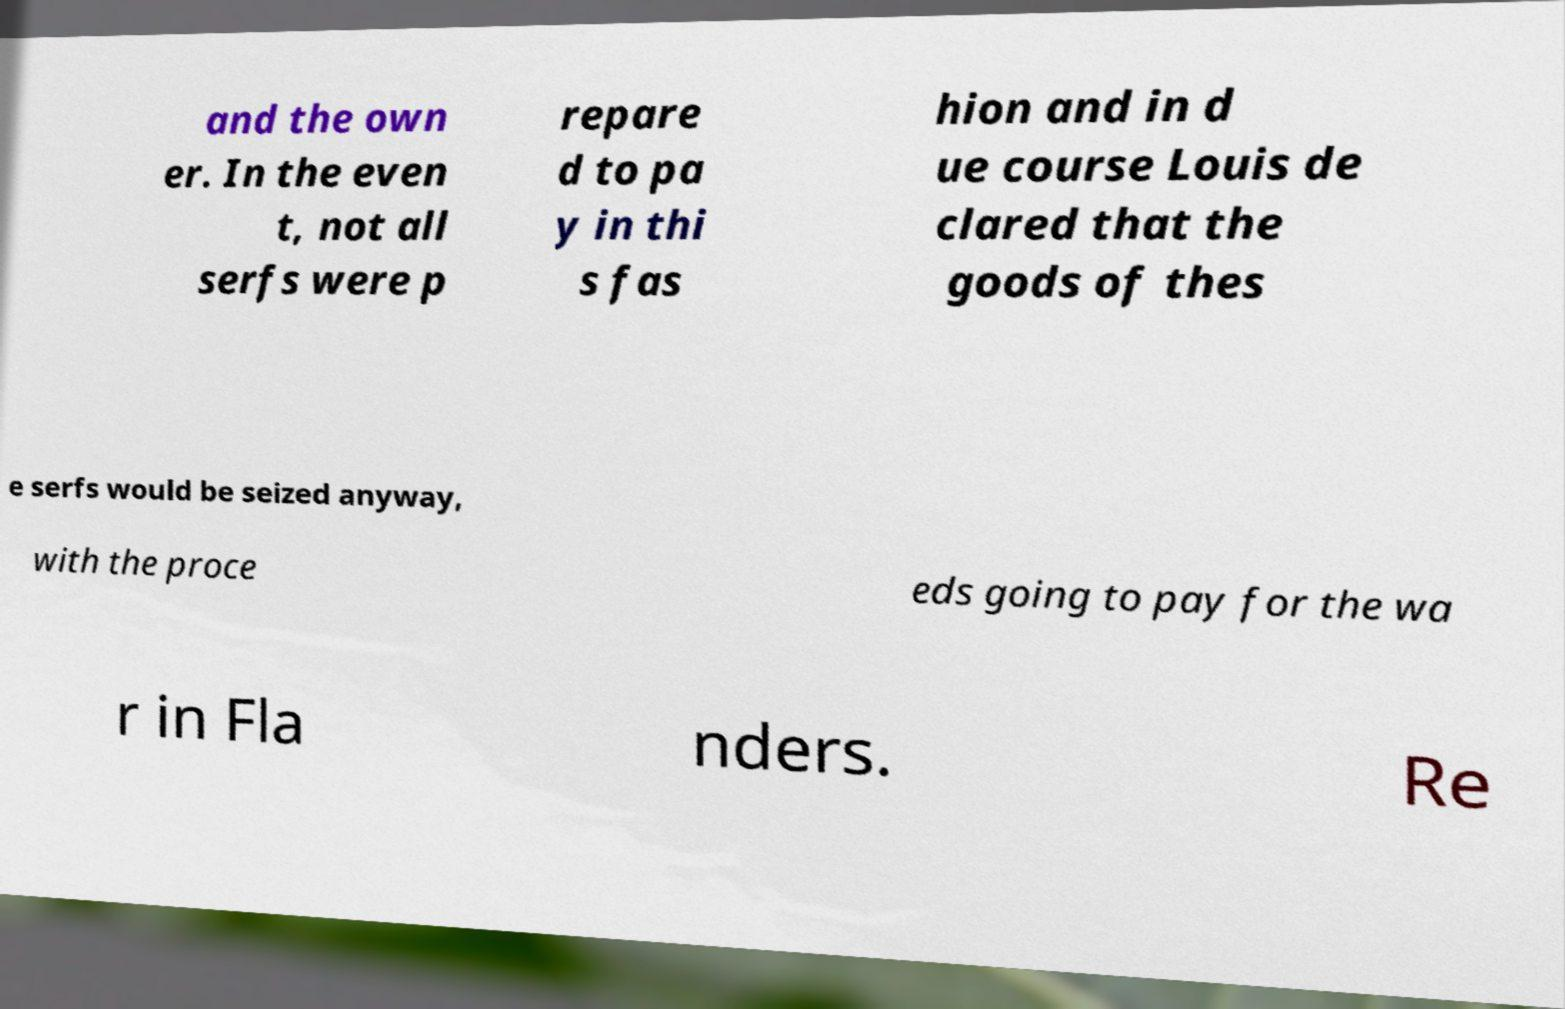Could you assist in decoding the text presented in this image and type it out clearly? and the own er. In the even t, not all serfs were p repare d to pa y in thi s fas hion and in d ue course Louis de clared that the goods of thes e serfs would be seized anyway, with the proce eds going to pay for the wa r in Fla nders. Re 